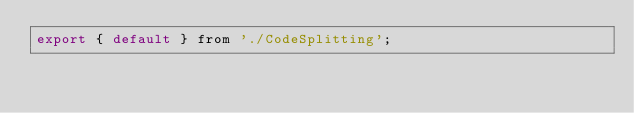<code> <loc_0><loc_0><loc_500><loc_500><_JavaScript_>export { default } from './CodeSplitting';
</code> 